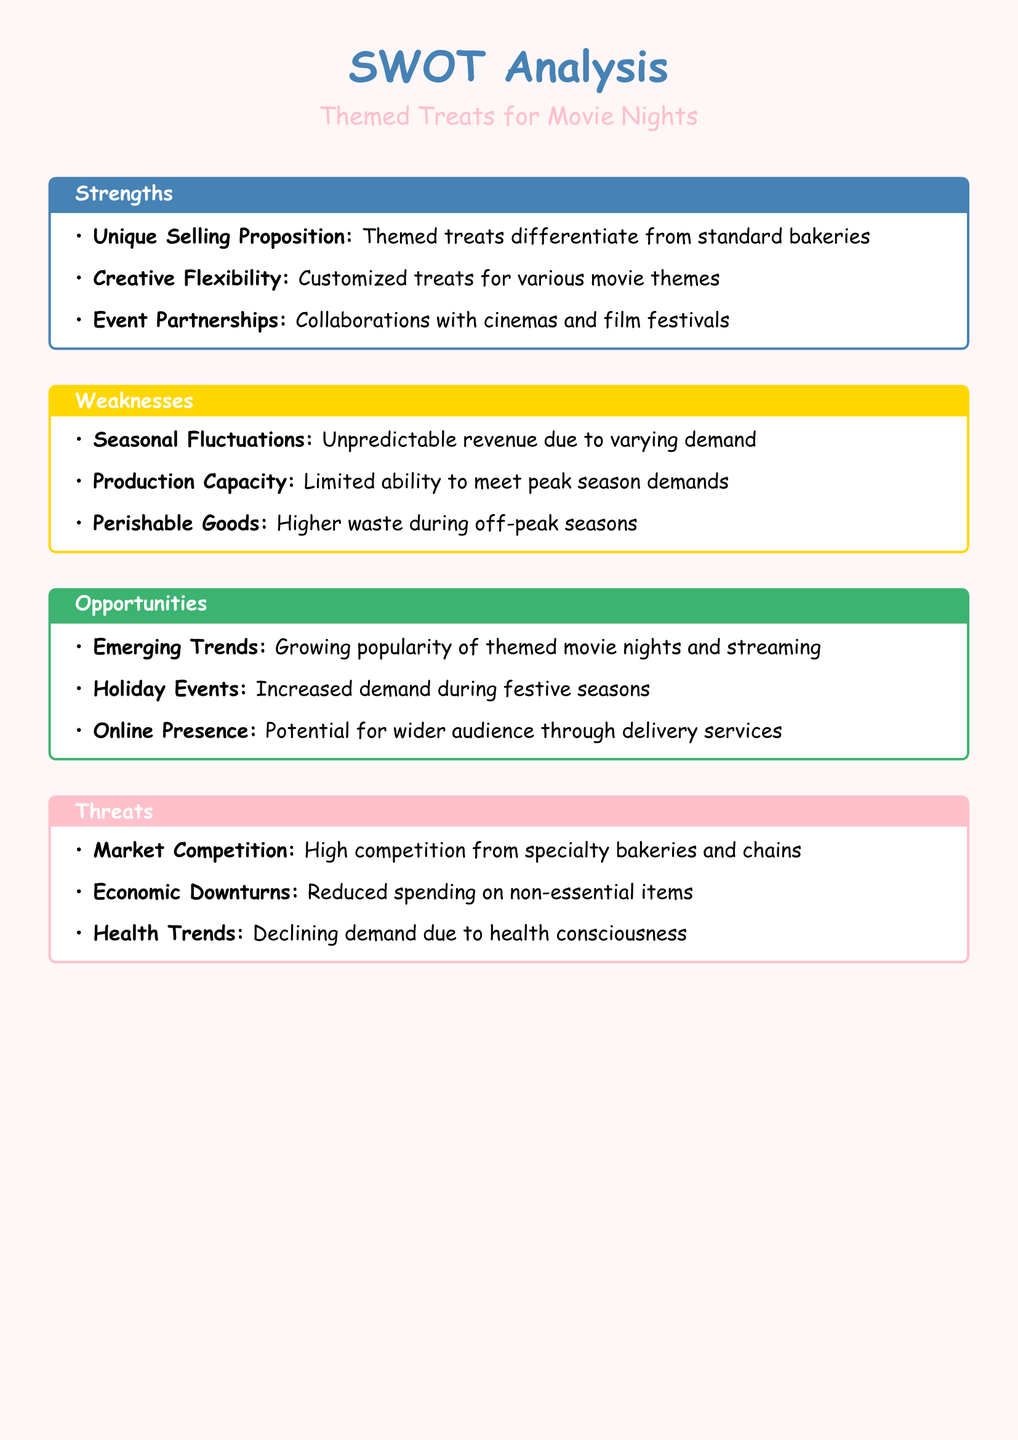What is the Unique Selling Proposition? The Unique Selling Proposition highlights the differentiation of themed treats from standard offerings in bakeries, explaining why customers should choose them.
Answer: Themed treats differentiate from standard bakeries What is one of the Weaknesses related to demand? One of the weaknesses pertains to the unpredictability and fluctuations in revenue due to varying seasonal demand for themed treats.
Answer: Unpredictable revenue due to varying demand What is noted as an Opportunity in the analysis? An opportunity discusses the growing trends in themed movie nights and streaming, which could benefit the bakery's offerings.
Answer: Growing popularity of themed movie nights and streaming What is a key threat mentioned? A significant threat includes competition from other specialty bakeries and chains, impacting market share.
Answer: High competition from specialty bakeries and chains How many strengths are identified? The document lists a total of three strengths that highlight the bakery's advantages in themed treats.
Answer: 3 What is the primary color theme of the document? The primary color theme utilizes a soft pink (bakeryPink) and blue (movieBlue) for the theme of a bakery analysis document.
Answer: BakeryPink, MovieBlue What role do Event Partnerships play in Strengths? Event partnerships with cinemas and film festivals are listed as a strength that enhances collaboration and visibility in the market.
Answer: Collaborations with cinemas and film festivals What issue does Limited Production Capacity represent? Limited production capacity signifies the difficulty that the bakery may have in meeting high demand during peak seasons, thus limiting sales.
Answer: Limited ability to meet peak season demands What season is highlighted for increased demand? The holiday season is specified as a time when demand for themed treats is expected to increase significantly.
Answer: Festive seasons What factor is affecting declining demand mentioned in Threats? The document notes health trends as a contributing factor to the declining demand in the marketplace for themed treats.
Answer: Health consciousness 